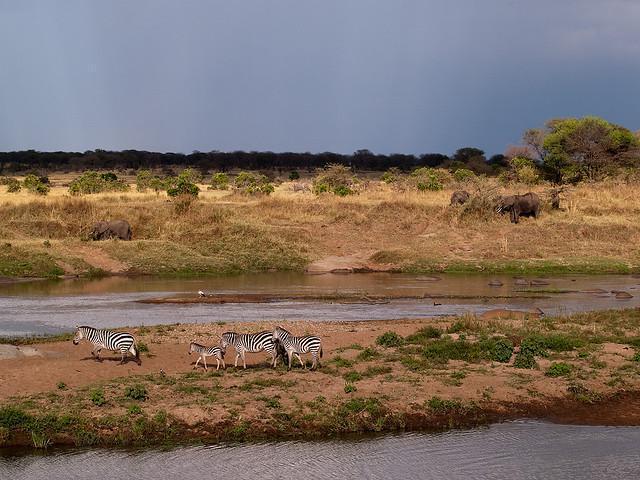How many fingers does the person on the left hold up on each hand in the image?
Give a very brief answer. 0. 